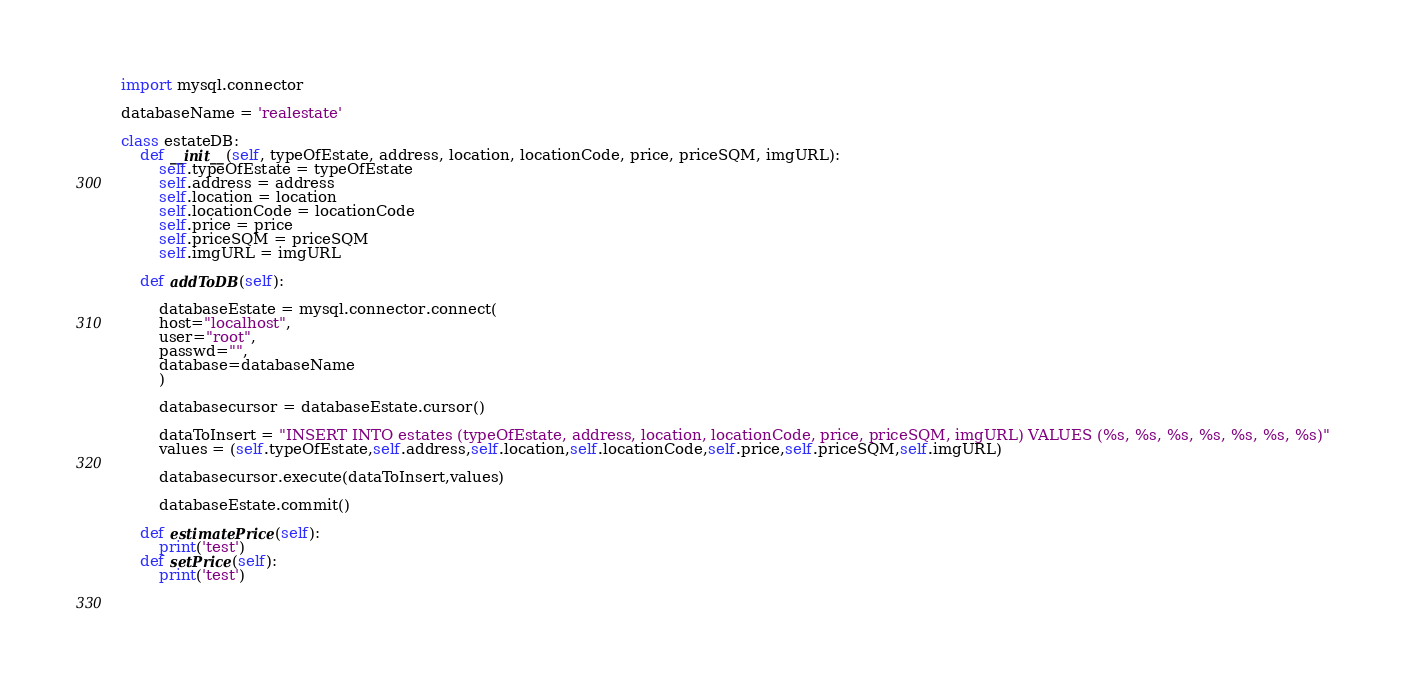Convert code to text. <code><loc_0><loc_0><loc_500><loc_500><_Python_>import mysql.connector

databaseName = 'realestate'

class estateDB:
    def __init__(self, typeOfEstate, address, location, locationCode, price, priceSQM, imgURL):
        self.typeOfEstate = typeOfEstate
        self.address = address
        self.location = location
        self.locationCode = locationCode
        self.price = price
        self.priceSQM = priceSQM
        self.imgURL = imgURL

    def addToDB(self):

        databaseEstate = mysql.connector.connect(
        host="localhost",
        user="root",
        passwd="",
        database=databaseName
        )

        databasecursor = databaseEstate.cursor()

        dataToInsert = "INSERT INTO estates (typeOfEstate, address, location, locationCode, price, priceSQM, imgURL) VALUES (%s, %s, %s, %s, %s, %s, %s)"
        values = (self.typeOfEstate,self.address,self.location,self.locationCode,self.price,self.priceSQM,self.imgURL)

        databasecursor.execute(dataToInsert,values)

        databaseEstate.commit()

    def estimatePrice(self):
        print('test')
    def setPrice(self):
        print('test')

        


</code> 